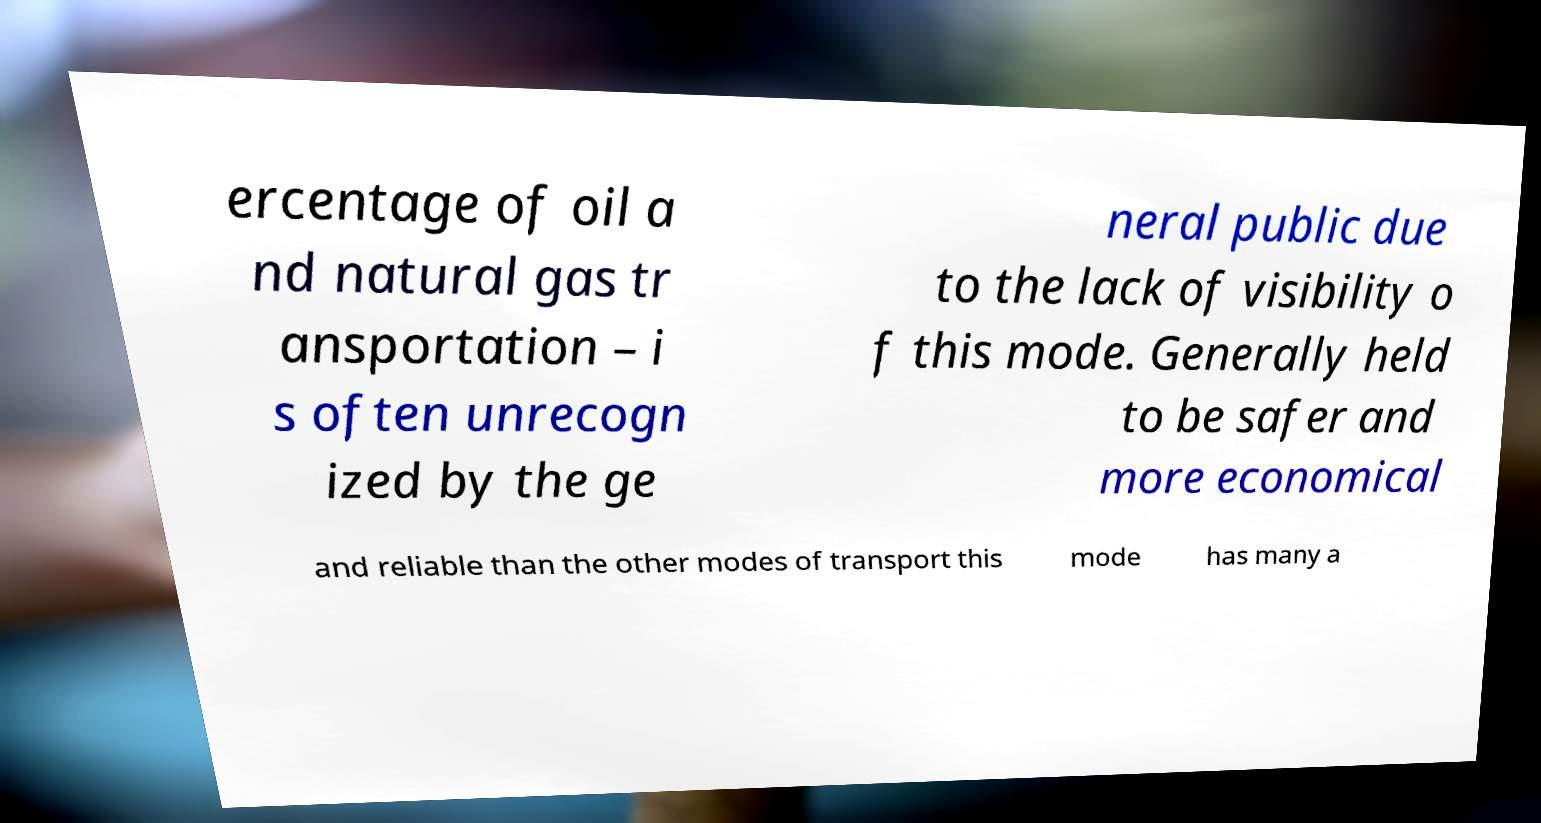Can you read and provide the text displayed in the image?This photo seems to have some interesting text. Can you extract and type it out for me? ercentage of oil a nd natural gas tr ansportation – i s often unrecogn ized by the ge neral public due to the lack of visibility o f this mode. Generally held to be safer and more economical and reliable than the other modes of transport this mode has many a 